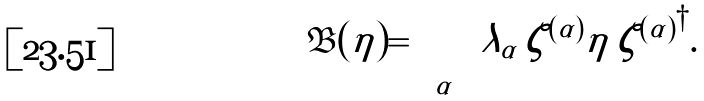<formula> <loc_0><loc_0><loc_500><loc_500>\mathfrak { B } ( \eta ) = \sum _ { \alpha } \lambda _ { \alpha } \, \zeta ^ { ( \alpha ) } \eta \, { \zeta ^ { ( \alpha ) } } ^ { \dagger } . \\</formula> 